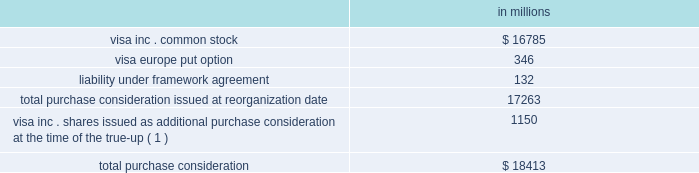Visa inc .
Notes to consolidated financial statements 2014 ( continued ) september 30 , 2008 ( in millions , except as noted ) purchase consideration total purchase consideration of approximately $ 17.3 billion was exchanged in october 2007 for the acquired interests .
The consideration was comprised of the following: .
( 1 ) see description of the true-up of purchase consideration below .
See note 4 2014visa europe for more information related to the visa europe put option and the liability under framework agreement .
Visa inc .
Common stock issued in exchange for the acquired regions the value of the purchase consideration conveyed to each of the member groups of the acquired regions was determined by valuing the underlying businesses contributed by each , after giving effect to negotiated adjustments .
The value of the purchase consideration , consisting of all outstanding shares of class canada , class ap , class lac and class cemea common stock , was measured at june 15 , 2007 ( the 201cmeasurement date 201d ) , the date on which all parties entered into the global restructuring agreement , and was determined to have a fair value of approximately $ 12.6 billion .
The company primarily relied upon the analysis of comparable companies with similar industry , business model and financial profiles .
This analysis considered a range of metrics including the forward multiples of revenue ; earnings before interest , depreciation and amortization ; and net income of comparable companies .
Ultimately , the company determined that the forward net income multiple was the most appropriate measure to value the acquired regions and reflect anticipated changes in the company 2019s financial profile prospectively .
This multiple was applied to the corresponding forward net income of the acquired regions to calculate their value .
The most comparable company identified was mastercard inc .
Therefore , the most significant input into this analysis was mastercard 2019s forward net income multiple of 27 times net income at the measurement date .
The company additionally performed discounted cash flow analyses for each region .
These analyses considered the company 2019s forecast by region and incorporated market participant assumptions for growth and profitability .
The cash flows were discounted using rates ranging from 12-16% ( 12-16 % ) , reflecting returns for investments times earnings before interest , tax , depreciation and amortization ( 201cebitda 201d ) to ascribe value to periods beyond the company 2019s forecast , consistent with recent payment processing , financial exchange and credit card precedent transactions. .
What portion of total purchase consideration issued at reorganization date is related to visa inc . common stock? 
Computations: (16785 / 17263)
Answer: 0.97231. 